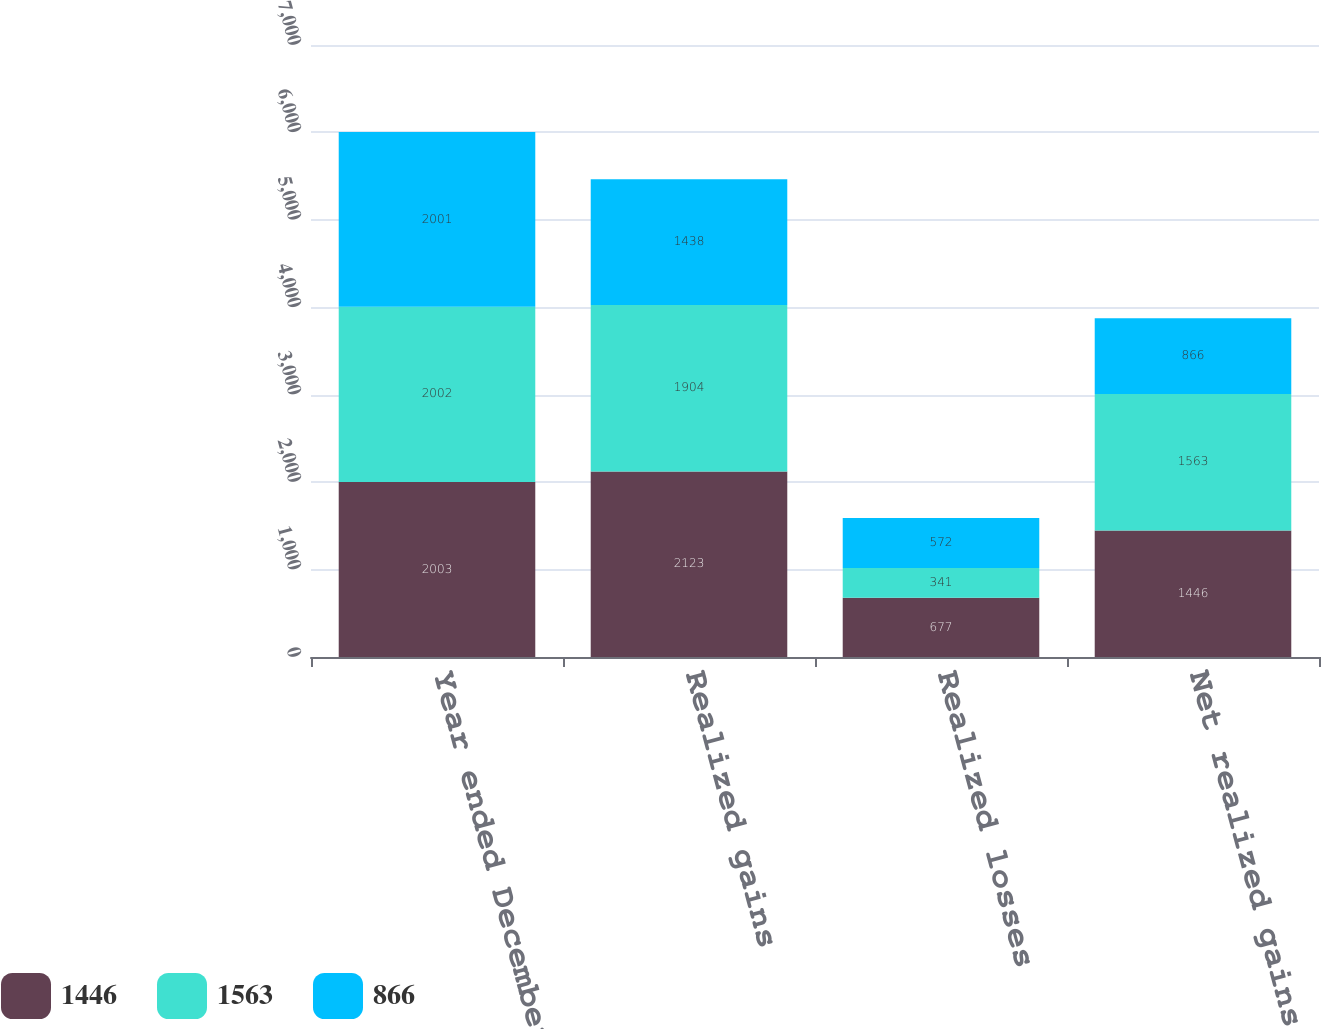Convert chart. <chart><loc_0><loc_0><loc_500><loc_500><stacked_bar_chart><ecel><fcel>Year ended December 31 (in<fcel>Realized gains<fcel>Realized losses<fcel>Net realized gains (losses)<nl><fcel>1446<fcel>2003<fcel>2123<fcel>677<fcel>1446<nl><fcel>1563<fcel>2002<fcel>1904<fcel>341<fcel>1563<nl><fcel>866<fcel>2001<fcel>1438<fcel>572<fcel>866<nl></chart> 